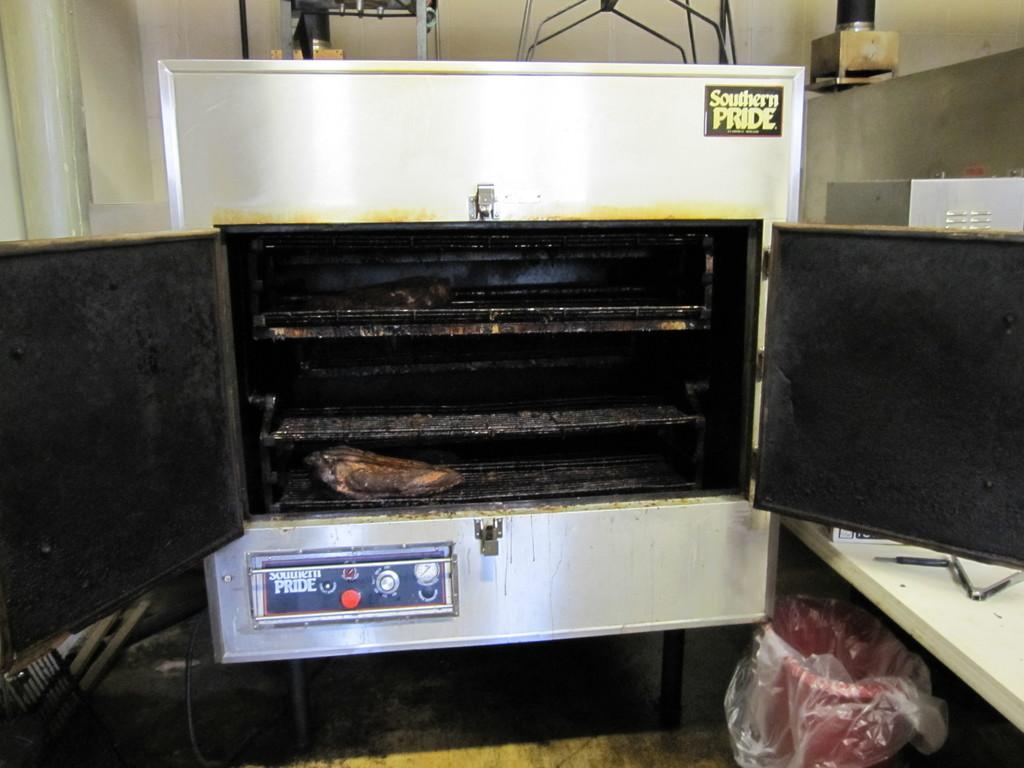<image>
Share a concise interpretation of the image provided. The dirty silver oven is made by Pride 